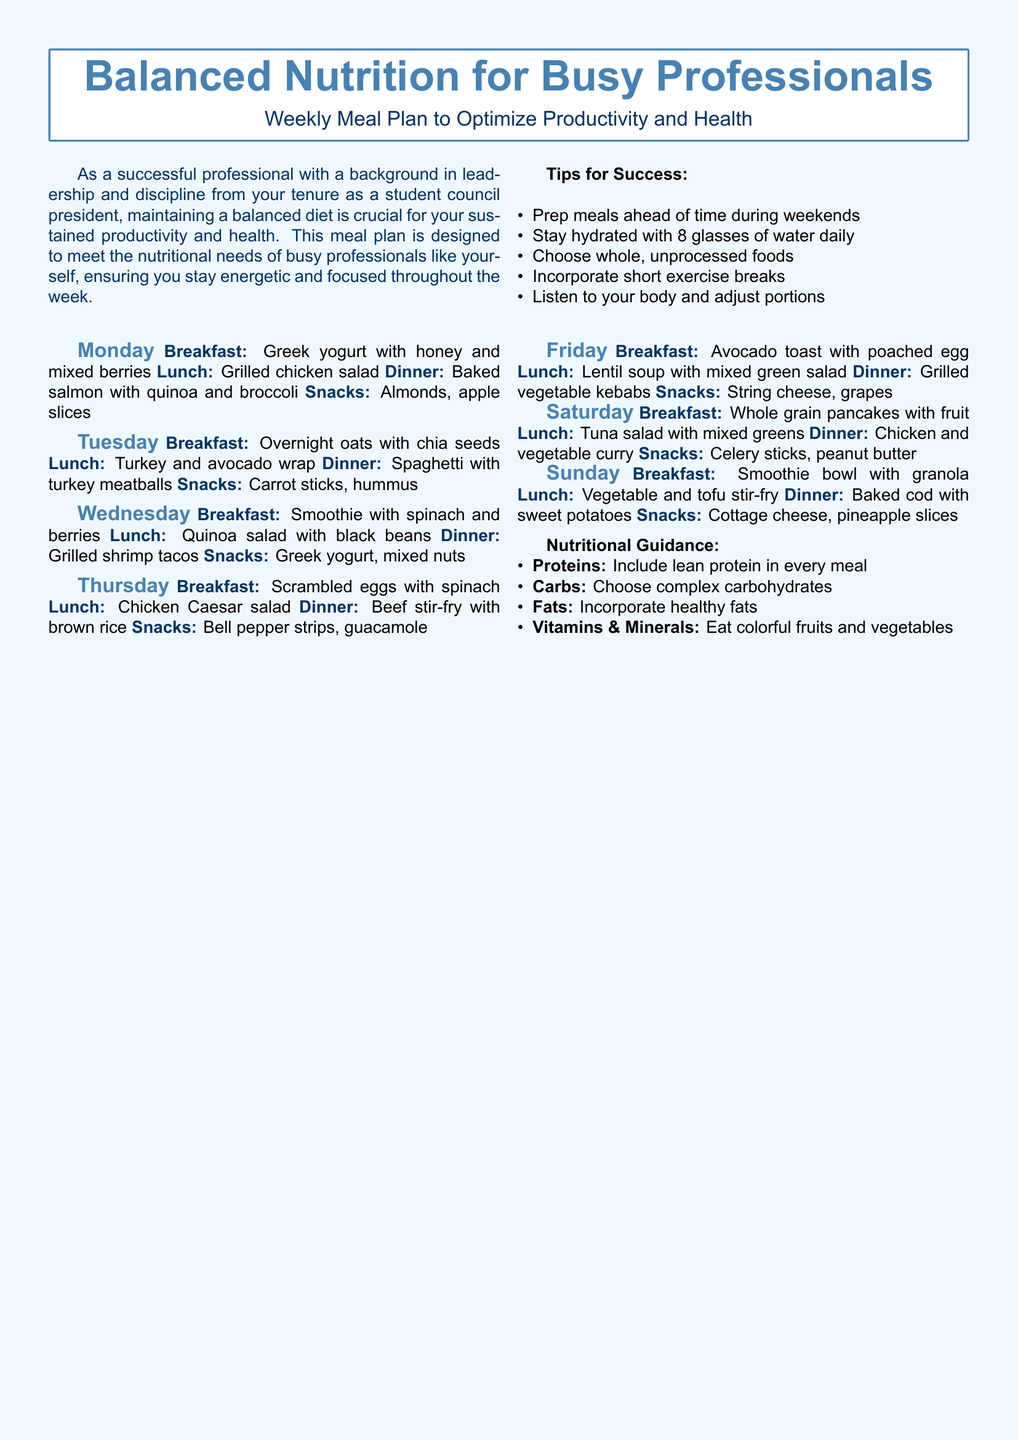What is the title of the meal plan? The title is found in the header of the document, which presents the main theme of the content.
Answer: Balanced Nutrition for Busy Professionals What is the suggested breakfast for Tuesday? The breakfast is listed under the Tuesday section of the meal plan.
Answer: Overnight oats with chia seeds What snack is recommended for Friday? The snack is specified in the meal plan for Friday, focusing on healthy options.
Answer: String cheese, grapes How many meals are planned for Sunday? The meals for Sunday include breakfast, lunch, dinner, and snacks, providing a full day's worth of nutrition.
Answer: Four What is a tip for success mentioned in the document? The tips for success are provided in a dedicated section for improving adherence to the meal plan.
Answer: Prep meals ahead of time during weekends What type of carbohydrates should be chosen according to the nutritional guidance? The nutritional guidance outlines specific recommendations regarding food choices, particularly for carbohydrates.
Answer: Complex carbohydrates What type of dish is proposed for Saturday's dinner? The meal type for Saturday evening is outlined in the weekly meal plan.
Answer: Chicken and vegetable curry Which day includes grilled shrimp tacos for dinner? The dinner options highlight specific meals assigned to each day of the week.
Answer: Wednesday 